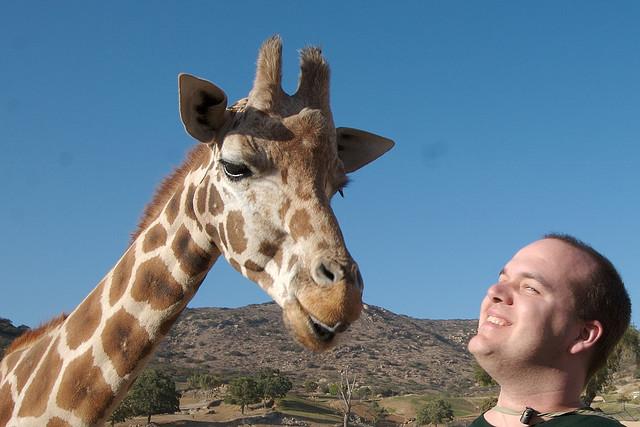Is giraffe happy?
Answer briefly. Yes. What is the condition of the sky?
Write a very short answer. Clear. Does this gentlemen look scared?
Be succinct. No. How many clouds are in the sky?
Short answer required. 0. 